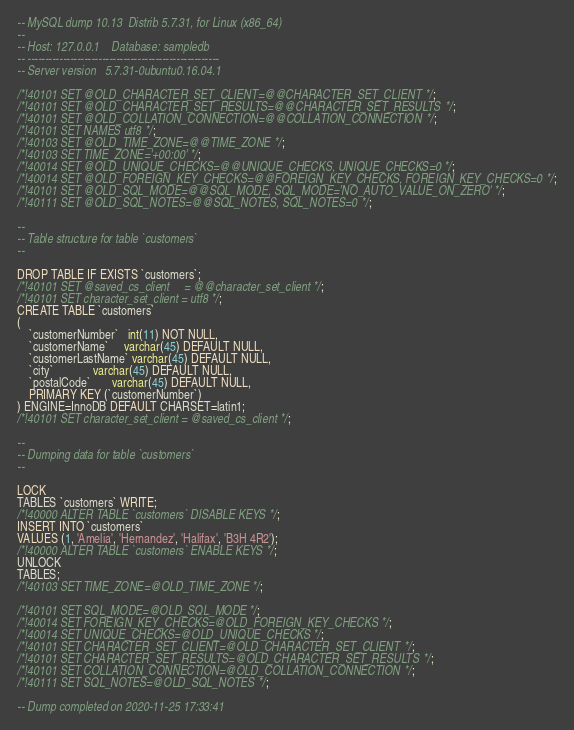<code> <loc_0><loc_0><loc_500><loc_500><_SQL_>-- MySQL dump 10.13  Distrib 5.7.31, for Linux (x86_64)
--
-- Host: 127.0.0.1    Database: sampledb
-- ------------------------------------------------------
-- Server version	5.7.31-0ubuntu0.16.04.1

/*!40101 SET @OLD_CHARACTER_SET_CLIENT=@@CHARACTER_SET_CLIENT */;
/*!40101 SET @OLD_CHARACTER_SET_RESULTS=@@CHARACTER_SET_RESULTS */;
/*!40101 SET @OLD_COLLATION_CONNECTION=@@COLLATION_CONNECTION */;
/*!40101 SET NAMES utf8 */;
/*!40103 SET @OLD_TIME_ZONE=@@TIME_ZONE */;
/*!40103 SET TIME_ZONE='+00:00' */;
/*!40014 SET @OLD_UNIQUE_CHECKS=@@UNIQUE_CHECKS, UNIQUE_CHECKS=0 */;
/*!40014 SET @OLD_FOREIGN_KEY_CHECKS=@@FOREIGN_KEY_CHECKS, FOREIGN_KEY_CHECKS=0 */;
/*!40101 SET @OLD_SQL_MODE=@@SQL_MODE, SQL_MODE='NO_AUTO_VALUE_ON_ZERO' */;
/*!40111 SET @OLD_SQL_NOTES=@@SQL_NOTES, SQL_NOTES=0 */;

--
-- Table structure for table `customers`
--

DROP TABLE IF EXISTS `customers`;
/*!40101 SET @saved_cs_client     = @@character_set_client */;
/*!40101 SET character_set_client = utf8 */;
CREATE TABLE `customers`
(
    `customerNumber`   int(11) NOT NULL,
    `customerName`     varchar(45) DEFAULT NULL,
    `customerLastName` varchar(45) DEFAULT NULL,
    `city`             varchar(45) DEFAULT NULL,
    `postalCode`       varchar(45) DEFAULT NULL,
    PRIMARY KEY (`customerNumber`)
) ENGINE=InnoDB DEFAULT CHARSET=latin1;
/*!40101 SET character_set_client = @saved_cs_client */;

--
-- Dumping data for table `customers`
--

LOCK
TABLES `customers` WRITE;
/*!40000 ALTER TABLE `customers` DISABLE KEYS */;
INSERT INTO `customers`
VALUES (1, 'Amelia', 'Hernandez', 'Halifax', 'B3H 4R2');
/*!40000 ALTER TABLE `customers` ENABLE KEYS */;
UNLOCK
TABLES;
/*!40103 SET TIME_ZONE=@OLD_TIME_ZONE */;

/*!40101 SET SQL_MODE=@OLD_SQL_MODE */;
/*!40014 SET FOREIGN_KEY_CHECKS=@OLD_FOREIGN_KEY_CHECKS */;
/*!40014 SET UNIQUE_CHECKS=@OLD_UNIQUE_CHECKS */;
/*!40101 SET CHARACTER_SET_CLIENT=@OLD_CHARACTER_SET_CLIENT */;
/*!40101 SET CHARACTER_SET_RESULTS=@OLD_CHARACTER_SET_RESULTS */;
/*!40101 SET COLLATION_CONNECTION=@OLD_COLLATION_CONNECTION */;
/*!40111 SET SQL_NOTES=@OLD_SQL_NOTES */;

-- Dump completed on 2020-11-25 17:33:41
</code> 